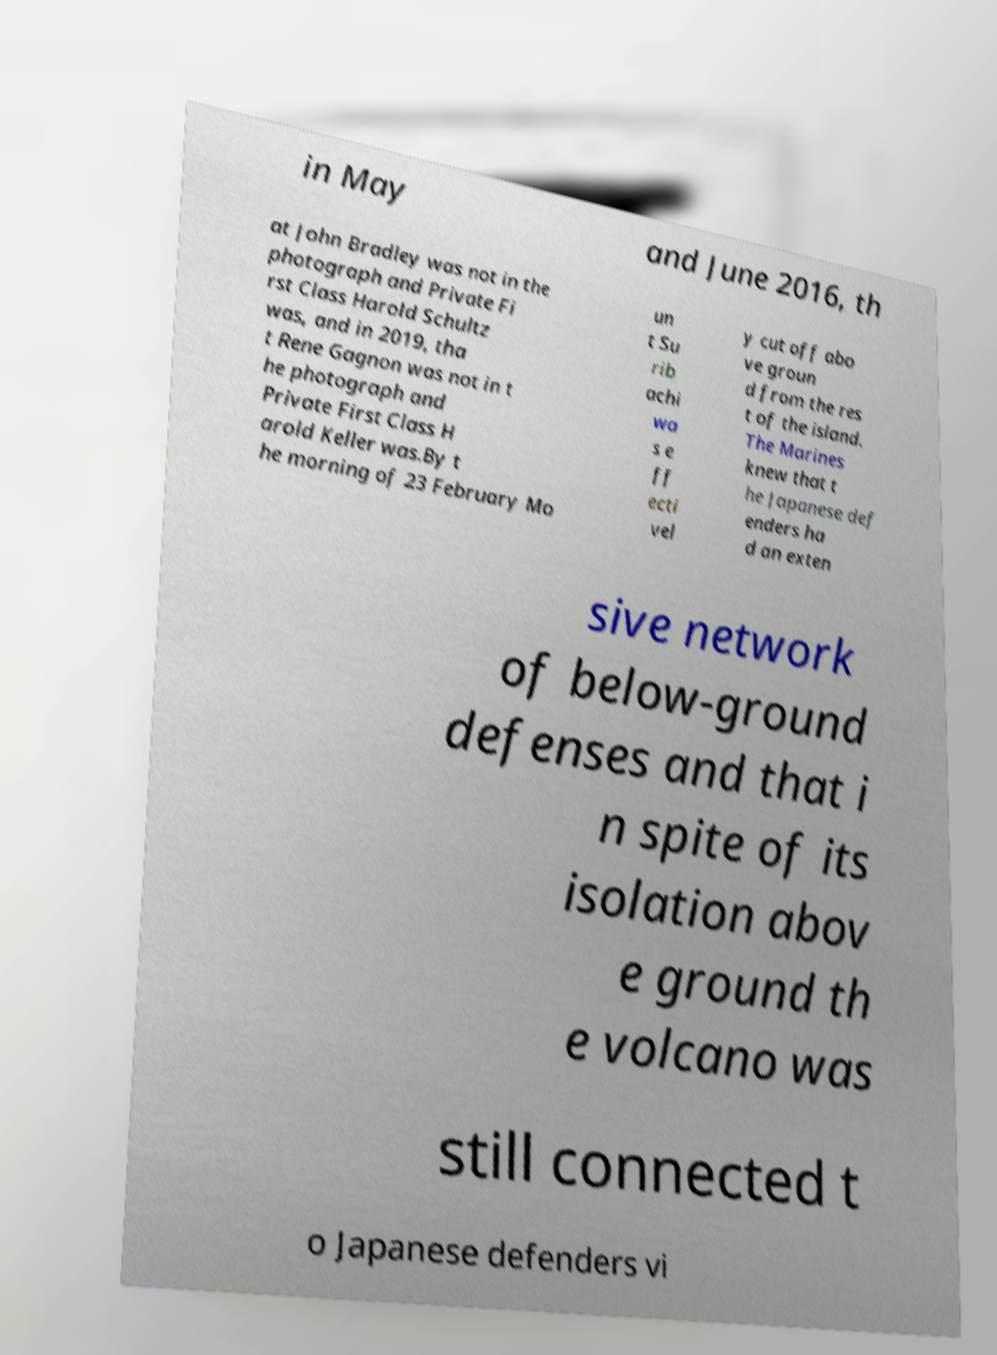There's text embedded in this image that I need extracted. Can you transcribe it verbatim? in May and June 2016, th at John Bradley was not in the photograph and Private Fi rst Class Harold Schultz was, and in 2019, tha t Rene Gagnon was not in t he photograph and Private First Class H arold Keller was.By t he morning of 23 February Mo un t Su rib achi wa s e ff ecti vel y cut off abo ve groun d from the res t of the island. The Marines knew that t he Japanese def enders ha d an exten sive network of below-ground defenses and that i n spite of its isolation abov e ground th e volcano was still connected t o Japanese defenders vi 